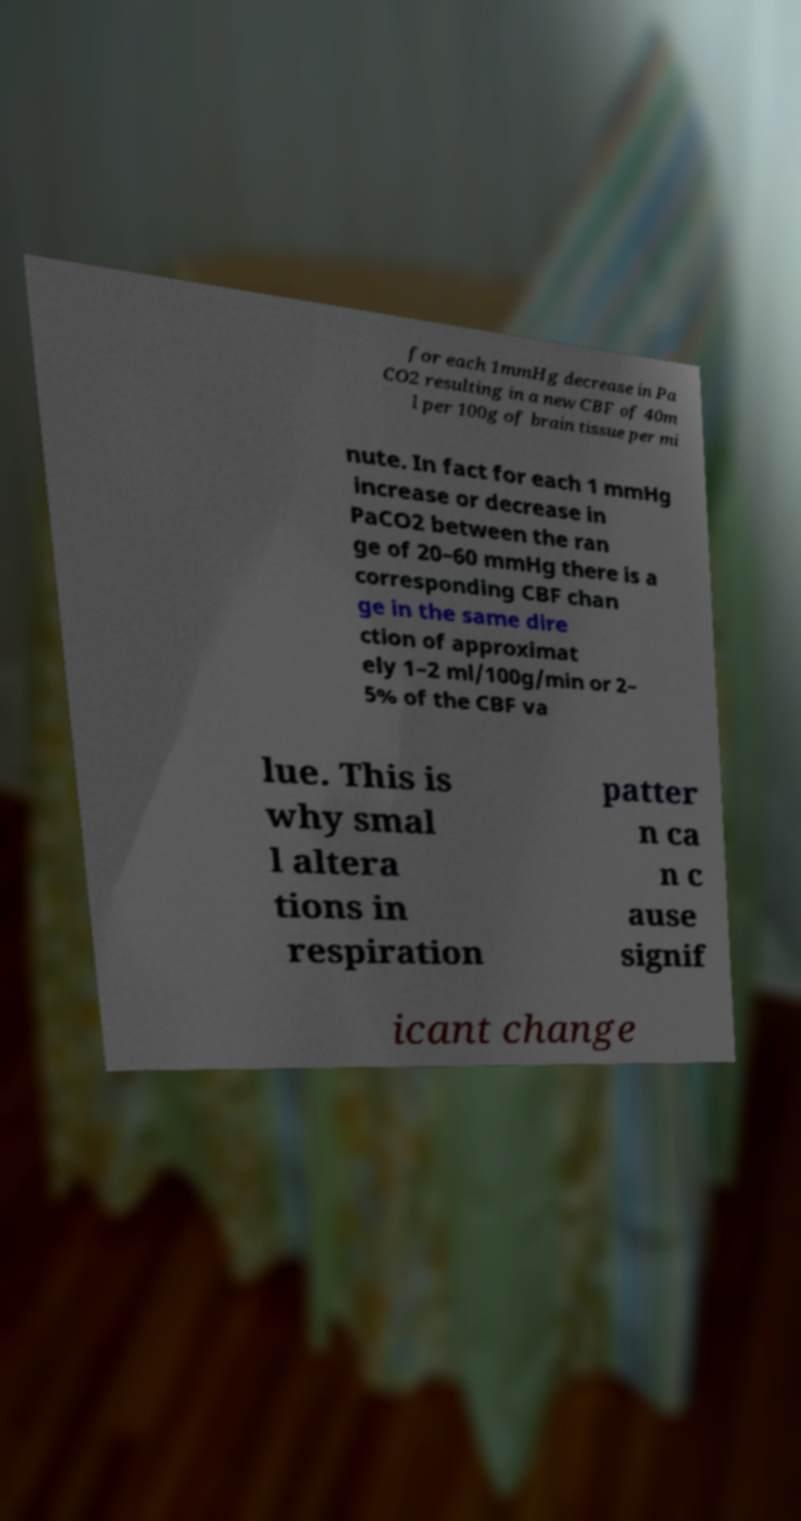Please identify and transcribe the text found in this image. for each 1mmHg decrease in Pa CO2 resulting in a new CBF of 40m l per 100g of brain tissue per mi nute. In fact for each 1 mmHg increase or decrease in PaCO2 between the ran ge of 20–60 mmHg there is a corresponding CBF chan ge in the same dire ction of approximat ely 1–2 ml/100g/min or 2– 5% of the CBF va lue. This is why smal l altera tions in respiration patter n ca n c ause signif icant change 